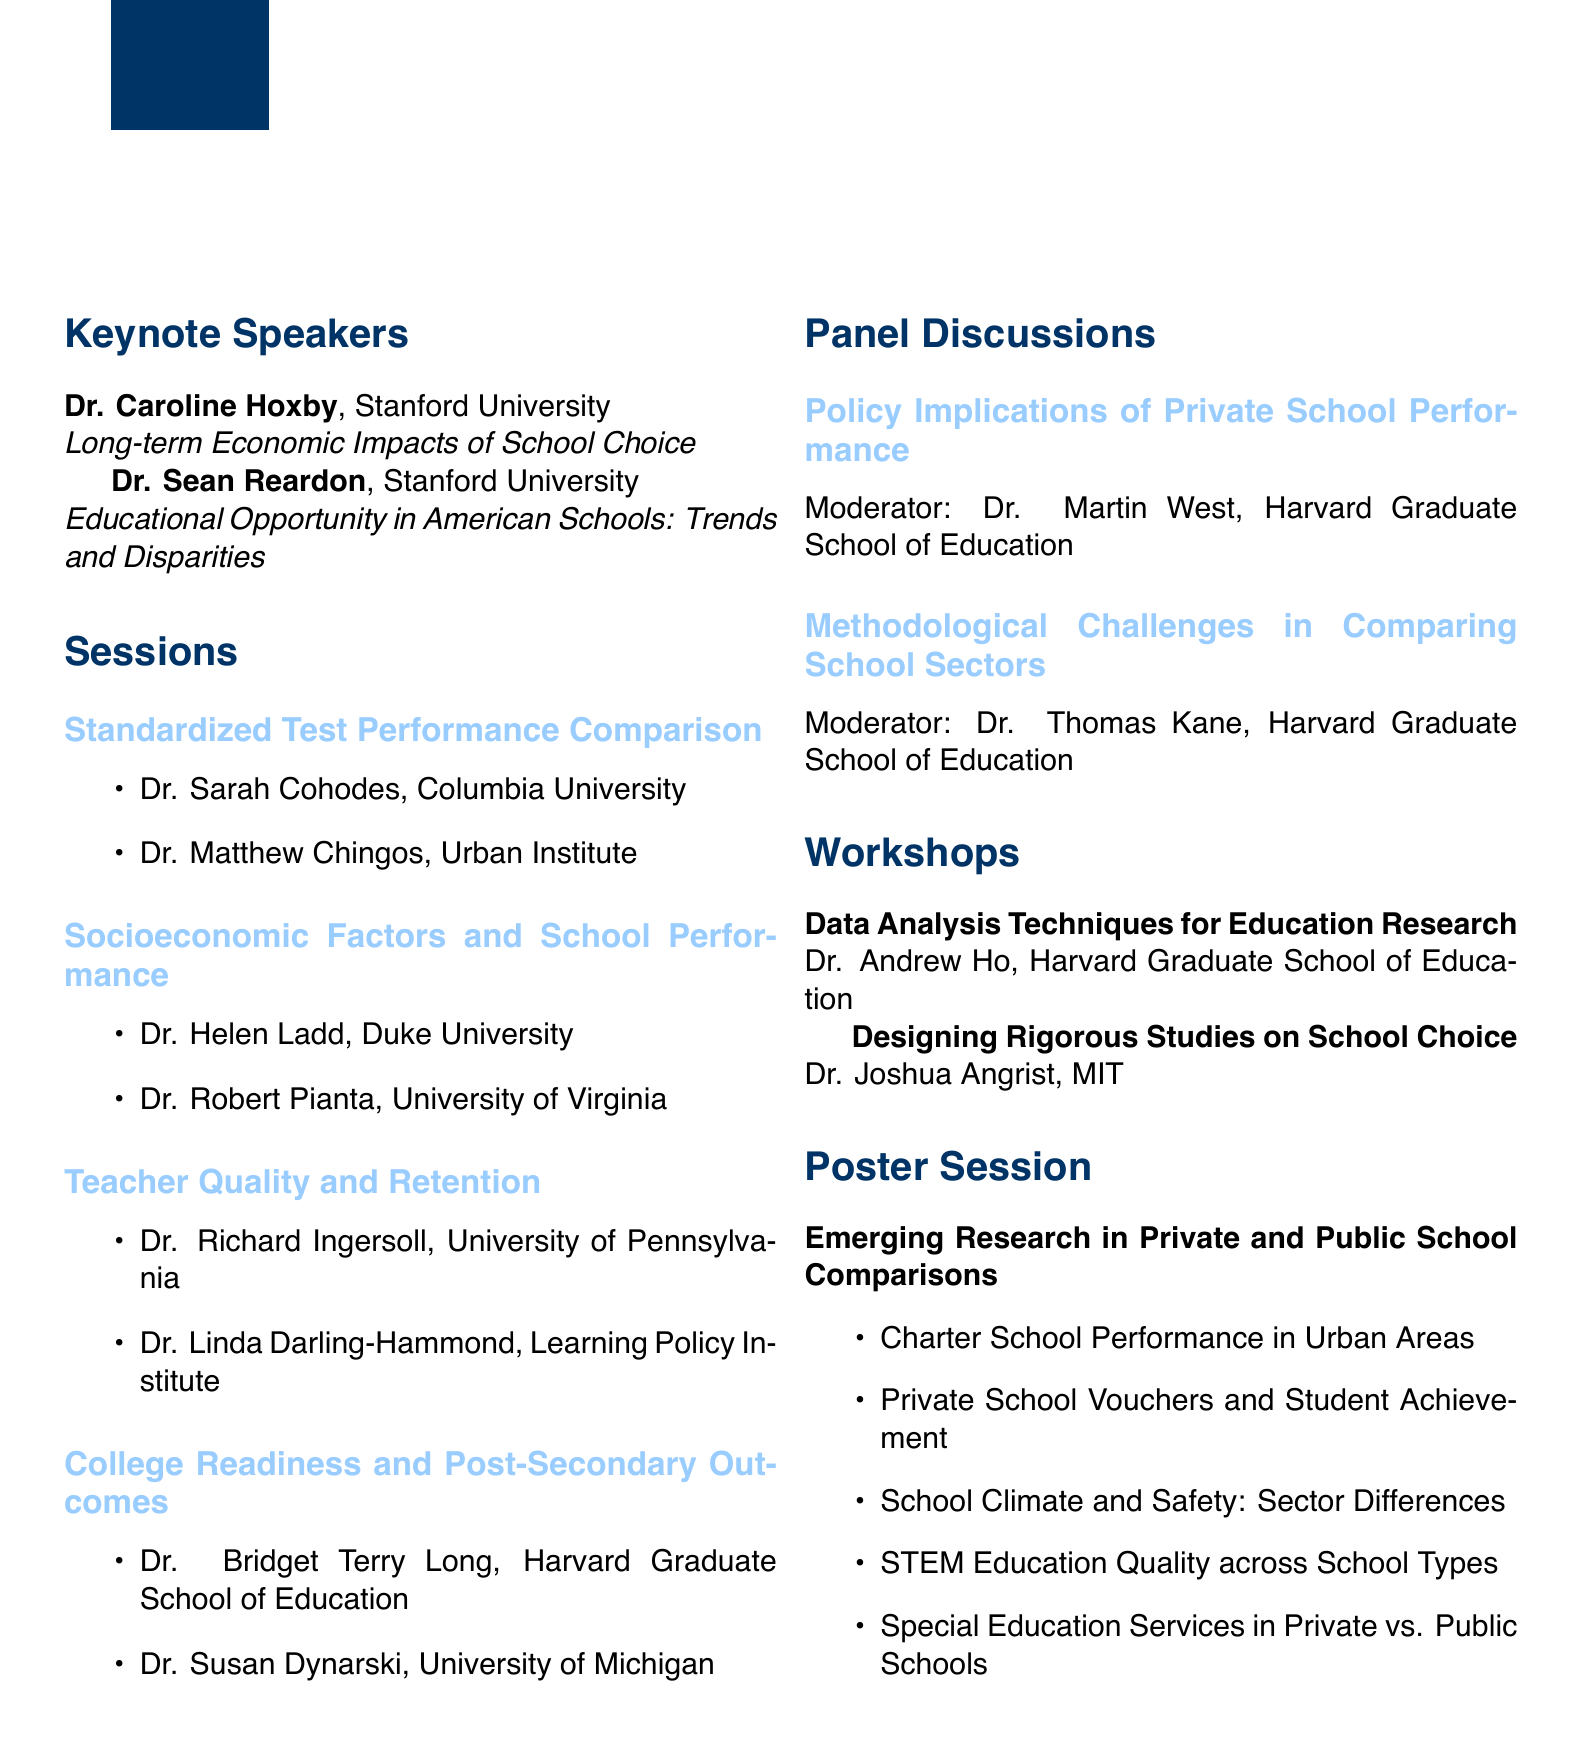What is the title of the seminar? The title of the seminar is mentioned at the beginning of the document.
Answer: Comparative Analysis of Private and Public School Performance Metrics What are the dates of the seminar? The dates are specified in the header of the document.
Answer: October 15-16, 2023 Who is the moderator of the panel discussion on policy implications? The moderator is named in the section discussing the panel discussions.
Answer: Dr. Martin West Which university is Dr. Bridget Terry Long affiliated with? The affiliation of Dr. Bridget Terry Long is listed in the sessions section.
Answer: Harvard Graduate School of Education What is the topic of Dr. Caroline Hoxby's keynote speech? The topic is provided alongside her name under keynote speakers.
Answer: Long-term Economic Impacts of School Choice What is the focus of the workshop led by Dr. Joshua Angrist? The workshop's focus is detailed alongside the instructor's name and title.
Answer: Designing Rigorous Studies on School Choice How many keynote speakers are listed in the document? The number of keynote speakers can be counted from the keynote speakers section.
Answer: 2 What is the theme of the poster session? The theme of the poster session is stated clearly in its title.
Answer: Emerging Research in Private and Public School Comparisons 